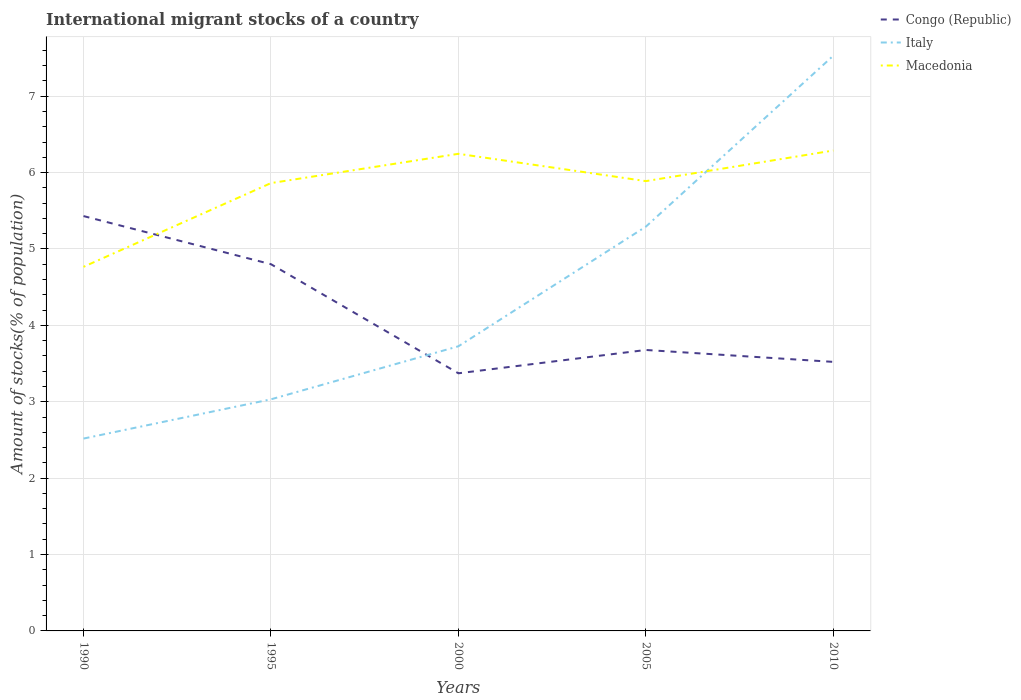Does the line corresponding to Macedonia intersect with the line corresponding to Congo (Republic)?
Provide a succinct answer. Yes. Is the number of lines equal to the number of legend labels?
Provide a short and direct response. Yes. Across all years, what is the maximum amount of stocks in in Macedonia?
Your answer should be compact. 4.77. What is the total amount of stocks in in Macedonia in the graph?
Your response must be concise. -0.38. What is the difference between the highest and the second highest amount of stocks in in Macedonia?
Your response must be concise. 1.52. What is the difference between the highest and the lowest amount of stocks in in Congo (Republic)?
Offer a terse response. 2. Is the amount of stocks in in Congo (Republic) strictly greater than the amount of stocks in in Italy over the years?
Ensure brevity in your answer.  No. How many lines are there?
Your answer should be compact. 3. Are the values on the major ticks of Y-axis written in scientific E-notation?
Offer a very short reply. No. Does the graph contain any zero values?
Make the answer very short. No. Where does the legend appear in the graph?
Provide a succinct answer. Top right. What is the title of the graph?
Your answer should be compact. International migrant stocks of a country. What is the label or title of the Y-axis?
Your response must be concise. Amount of stocks(% of population). What is the Amount of stocks(% of population) in Congo (Republic) in 1990?
Provide a short and direct response. 5.43. What is the Amount of stocks(% of population) in Italy in 1990?
Your response must be concise. 2.52. What is the Amount of stocks(% of population) of Macedonia in 1990?
Offer a terse response. 4.77. What is the Amount of stocks(% of population) in Congo (Republic) in 1995?
Your answer should be compact. 4.8. What is the Amount of stocks(% of population) of Italy in 1995?
Your response must be concise. 3.03. What is the Amount of stocks(% of population) of Macedonia in 1995?
Ensure brevity in your answer.  5.86. What is the Amount of stocks(% of population) in Congo (Republic) in 2000?
Ensure brevity in your answer.  3.37. What is the Amount of stocks(% of population) of Italy in 2000?
Offer a very short reply. 3.73. What is the Amount of stocks(% of population) in Macedonia in 2000?
Your response must be concise. 6.25. What is the Amount of stocks(% of population) of Congo (Republic) in 2005?
Keep it short and to the point. 3.68. What is the Amount of stocks(% of population) of Italy in 2005?
Ensure brevity in your answer.  5.29. What is the Amount of stocks(% of population) in Macedonia in 2005?
Provide a succinct answer. 5.89. What is the Amount of stocks(% of population) of Congo (Republic) in 2010?
Offer a very short reply. 3.52. What is the Amount of stocks(% of population) in Italy in 2010?
Make the answer very short. 7.53. What is the Amount of stocks(% of population) of Macedonia in 2010?
Your response must be concise. 6.29. Across all years, what is the maximum Amount of stocks(% of population) in Congo (Republic)?
Ensure brevity in your answer.  5.43. Across all years, what is the maximum Amount of stocks(% of population) in Italy?
Keep it short and to the point. 7.53. Across all years, what is the maximum Amount of stocks(% of population) in Macedonia?
Your answer should be very brief. 6.29. Across all years, what is the minimum Amount of stocks(% of population) in Congo (Republic)?
Give a very brief answer. 3.37. Across all years, what is the minimum Amount of stocks(% of population) in Italy?
Give a very brief answer. 2.52. Across all years, what is the minimum Amount of stocks(% of population) in Macedonia?
Make the answer very short. 4.77. What is the total Amount of stocks(% of population) of Congo (Republic) in the graph?
Offer a terse response. 20.8. What is the total Amount of stocks(% of population) in Italy in the graph?
Provide a succinct answer. 22.1. What is the total Amount of stocks(% of population) of Macedonia in the graph?
Your response must be concise. 29.05. What is the difference between the Amount of stocks(% of population) in Congo (Republic) in 1990 and that in 1995?
Ensure brevity in your answer.  0.63. What is the difference between the Amount of stocks(% of population) in Italy in 1990 and that in 1995?
Provide a succinct answer. -0.51. What is the difference between the Amount of stocks(% of population) of Macedonia in 1990 and that in 1995?
Give a very brief answer. -1.1. What is the difference between the Amount of stocks(% of population) of Congo (Republic) in 1990 and that in 2000?
Make the answer very short. 2.06. What is the difference between the Amount of stocks(% of population) of Italy in 1990 and that in 2000?
Give a very brief answer. -1.21. What is the difference between the Amount of stocks(% of population) of Macedonia in 1990 and that in 2000?
Make the answer very short. -1.48. What is the difference between the Amount of stocks(% of population) in Congo (Republic) in 1990 and that in 2005?
Ensure brevity in your answer.  1.75. What is the difference between the Amount of stocks(% of population) in Italy in 1990 and that in 2005?
Offer a terse response. -2.77. What is the difference between the Amount of stocks(% of population) in Macedonia in 1990 and that in 2005?
Offer a terse response. -1.12. What is the difference between the Amount of stocks(% of population) in Congo (Republic) in 1990 and that in 2010?
Offer a terse response. 1.91. What is the difference between the Amount of stocks(% of population) of Italy in 1990 and that in 2010?
Give a very brief answer. -5.01. What is the difference between the Amount of stocks(% of population) in Macedonia in 1990 and that in 2010?
Provide a succinct answer. -1.52. What is the difference between the Amount of stocks(% of population) in Congo (Republic) in 1995 and that in 2000?
Make the answer very short. 1.43. What is the difference between the Amount of stocks(% of population) in Italy in 1995 and that in 2000?
Give a very brief answer. -0.69. What is the difference between the Amount of stocks(% of population) of Macedonia in 1995 and that in 2000?
Keep it short and to the point. -0.38. What is the difference between the Amount of stocks(% of population) in Congo (Republic) in 1995 and that in 2005?
Your answer should be very brief. 1.12. What is the difference between the Amount of stocks(% of population) in Italy in 1995 and that in 2005?
Your response must be concise. -2.26. What is the difference between the Amount of stocks(% of population) of Macedonia in 1995 and that in 2005?
Your answer should be compact. -0.03. What is the difference between the Amount of stocks(% of population) of Congo (Republic) in 1995 and that in 2010?
Ensure brevity in your answer.  1.28. What is the difference between the Amount of stocks(% of population) in Italy in 1995 and that in 2010?
Make the answer very short. -4.5. What is the difference between the Amount of stocks(% of population) of Macedonia in 1995 and that in 2010?
Provide a short and direct response. -0.43. What is the difference between the Amount of stocks(% of population) in Congo (Republic) in 2000 and that in 2005?
Offer a very short reply. -0.31. What is the difference between the Amount of stocks(% of population) in Italy in 2000 and that in 2005?
Make the answer very short. -1.57. What is the difference between the Amount of stocks(% of population) in Macedonia in 2000 and that in 2005?
Your response must be concise. 0.36. What is the difference between the Amount of stocks(% of population) in Congo (Republic) in 2000 and that in 2010?
Your response must be concise. -0.15. What is the difference between the Amount of stocks(% of population) of Italy in 2000 and that in 2010?
Provide a short and direct response. -3.8. What is the difference between the Amount of stocks(% of population) of Macedonia in 2000 and that in 2010?
Your answer should be very brief. -0.04. What is the difference between the Amount of stocks(% of population) of Congo (Republic) in 2005 and that in 2010?
Your response must be concise. 0.16. What is the difference between the Amount of stocks(% of population) of Italy in 2005 and that in 2010?
Make the answer very short. -2.24. What is the difference between the Amount of stocks(% of population) of Macedonia in 2005 and that in 2010?
Offer a very short reply. -0.4. What is the difference between the Amount of stocks(% of population) of Congo (Republic) in 1990 and the Amount of stocks(% of population) of Italy in 1995?
Provide a succinct answer. 2.4. What is the difference between the Amount of stocks(% of population) of Congo (Republic) in 1990 and the Amount of stocks(% of population) of Macedonia in 1995?
Your answer should be compact. -0.43. What is the difference between the Amount of stocks(% of population) of Italy in 1990 and the Amount of stocks(% of population) of Macedonia in 1995?
Your response must be concise. -3.34. What is the difference between the Amount of stocks(% of population) of Congo (Republic) in 1990 and the Amount of stocks(% of population) of Italy in 2000?
Ensure brevity in your answer.  1.7. What is the difference between the Amount of stocks(% of population) in Congo (Republic) in 1990 and the Amount of stocks(% of population) in Macedonia in 2000?
Your answer should be compact. -0.82. What is the difference between the Amount of stocks(% of population) in Italy in 1990 and the Amount of stocks(% of population) in Macedonia in 2000?
Offer a terse response. -3.73. What is the difference between the Amount of stocks(% of population) in Congo (Republic) in 1990 and the Amount of stocks(% of population) in Italy in 2005?
Keep it short and to the point. 0.14. What is the difference between the Amount of stocks(% of population) in Congo (Republic) in 1990 and the Amount of stocks(% of population) in Macedonia in 2005?
Your answer should be compact. -0.46. What is the difference between the Amount of stocks(% of population) in Italy in 1990 and the Amount of stocks(% of population) in Macedonia in 2005?
Provide a short and direct response. -3.37. What is the difference between the Amount of stocks(% of population) in Congo (Republic) in 1990 and the Amount of stocks(% of population) in Italy in 2010?
Your answer should be compact. -2.1. What is the difference between the Amount of stocks(% of population) of Congo (Republic) in 1990 and the Amount of stocks(% of population) of Macedonia in 2010?
Your response must be concise. -0.86. What is the difference between the Amount of stocks(% of population) of Italy in 1990 and the Amount of stocks(% of population) of Macedonia in 2010?
Ensure brevity in your answer.  -3.77. What is the difference between the Amount of stocks(% of population) of Congo (Republic) in 1995 and the Amount of stocks(% of population) of Italy in 2000?
Provide a short and direct response. 1.07. What is the difference between the Amount of stocks(% of population) of Congo (Republic) in 1995 and the Amount of stocks(% of population) of Macedonia in 2000?
Ensure brevity in your answer.  -1.45. What is the difference between the Amount of stocks(% of population) of Italy in 1995 and the Amount of stocks(% of population) of Macedonia in 2000?
Your answer should be very brief. -3.21. What is the difference between the Amount of stocks(% of population) in Congo (Republic) in 1995 and the Amount of stocks(% of population) in Italy in 2005?
Provide a succinct answer. -0.49. What is the difference between the Amount of stocks(% of population) of Congo (Republic) in 1995 and the Amount of stocks(% of population) of Macedonia in 2005?
Provide a succinct answer. -1.09. What is the difference between the Amount of stocks(% of population) in Italy in 1995 and the Amount of stocks(% of population) in Macedonia in 2005?
Ensure brevity in your answer.  -2.86. What is the difference between the Amount of stocks(% of population) in Congo (Republic) in 1995 and the Amount of stocks(% of population) in Italy in 2010?
Give a very brief answer. -2.73. What is the difference between the Amount of stocks(% of population) of Congo (Republic) in 1995 and the Amount of stocks(% of population) of Macedonia in 2010?
Keep it short and to the point. -1.49. What is the difference between the Amount of stocks(% of population) of Italy in 1995 and the Amount of stocks(% of population) of Macedonia in 2010?
Keep it short and to the point. -3.26. What is the difference between the Amount of stocks(% of population) of Congo (Republic) in 2000 and the Amount of stocks(% of population) of Italy in 2005?
Make the answer very short. -1.92. What is the difference between the Amount of stocks(% of population) in Congo (Republic) in 2000 and the Amount of stocks(% of population) in Macedonia in 2005?
Your response must be concise. -2.52. What is the difference between the Amount of stocks(% of population) of Italy in 2000 and the Amount of stocks(% of population) of Macedonia in 2005?
Provide a short and direct response. -2.16. What is the difference between the Amount of stocks(% of population) of Congo (Republic) in 2000 and the Amount of stocks(% of population) of Italy in 2010?
Keep it short and to the point. -4.16. What is the difference between the Amount of stocks(% of population) of Congo (Republic) in 2000 and the Amount of stocks(% of population) of Macedonia in 2010?
Provide a short and direct response. -2.92. What is the difference between the Amount of stocks(% of population) of Italy in 2000 and the Amount of stocks(% of population) of Macedonia in 2010?
Provide a succinct answer. -2.56. What is the difference between the Amount of stocks(% of population) in Congo (Republic) in 2005 and the Amount of stocks(% of population) in Italy in 2010?
Your answer should be compact. -3.85. What is the difference between the Amount of stocks(% of population) in Congo (Republic) in 2005 and the Amount of stocks(% of population) in Macedonia in 2010?
Keep it short and to the point. -2.61. What is the difference between the Amount of stocks(% of population) in Italy in 2005 and the Amount of stocks(% of population) in Macedonia in 2010?
Provide a succinct answer. -1. What is the average Amount of stocks(% of population) of Congo (Republic) per year?
Keep it short and to the point. 4.16. What is the average Amount of stocks(% of population) of Italy per year?
Keep it short and to the point. 4.42. What is the average Amount of stocks(% of population) in Macedonia per year?
Offer a terse response. 5.81. In the year 1990, what is the difference between the Amount of stocks(% of population) of Congo (Republic) and Amount of stocks(% of population) of Italy?
Provide a short and direct response. 2.91. In the year 1990, what is the difference between the Amount of stocks(% of population) of Congo (Republic) and Amount of stocks(% of population) of Macedonia?
Your response must be concise. 0.66. In the year 1990, what is the difference between the Amount of stocks(% of population) of Italy and Amount of stocks(% of population) of Macedonia?
Provide a short and direct response. -2.25. In the year 1995, what is the difference between the Amount of stocks(% of population) of Congo (Republic) and Amount of stocks(% of population) of Italy?
Give a very brief answer. 1.77. In the year 1995, what is the difference between the Amount of stocks(% of population) in Congo (Republic) and Amount of stocks(% of population) in Macedonia?
Your response must be concise. -1.06. In the year 1995, what is the difference between the Amount of stocks(% of population) of Italy and Amount of stocks(% of population) of Macedonia?
Your answer should be compact. -2.83. In the year 2000, what is the difference between the Amount of stocks(% of population) of Congo (Republic) and Amount of stocks(% of population) of Italy?
Your response must be concise. -0.35. In the year 2000, what is the difference between the Amount of stocks(% of population) of Congo (Republic) and Amount of stocks(% of population) of Macedonia?
Ensure brevity in your answer.  -2.87. In the year 2000, what is the difference between the Amount of stocks(% of population) in Italy and Amount of stocks(% of population) in Macedonia?
Your answer should be very brief. -2.52. In the year 2005, what is the difference between the Amount of stocks(% of population) of Congo (Republic) and Amount of stocks(% of population) of Italy?
Give a very brief answer. -1.61. In the year 2005, what is the difference between the Amount of stocks(% of population) of Congo (Republic) and Amount of stocks(% of population) of Macedonia?
Your response must be concise. -2.21. In the year 2005, what is the difference between the Amount of stocks(% of population) of Italy and Amount of stocks(% of population) of Macedonia?
Make the answer very short. -0.6. In the year 2010, what is the difference between the Amount of stocks(% of population) in Congo (Republic) and Amount of stocks(% of population) in Italy?
Keep it short and to the point. -4.01. In the year 2010, what is the difference between the Amount of stocks(% of population) of Congo (Republic) and Amount of stocks(% of population) of Macedonia?
Provide a succinct answer. -2.77. In the year 2010, what is the difference between the Amount of stocks(% of population) of Italy and Amount of stocks(% of population) of Macedonia?
Give a very brief answer. 1.24. What is the ratio of the Amount of stocks(% of population) in Congo (Republic) in 1990 to that in 1995?
Provide a short and direct response. 1.13. What is the ratio of the Amount of stocks(% of population) of Italy in 1990 to that in 1995?
Ensure brevity in your answer.  0.83. What is the ratio of the Amount of stocks(% of population) in Macedonia in 1990 to that in 1995?
Offer a terse response. 0.81. What is the ratio of the Amount of stocks(% of population) of Congo (Republic) in 1990 to that in 2000?
Your response must be concise. 1.61. What is the ratio of the Amount of stocks(% of population) of Italy in 1990 to that in 2000?
Ensure brevity in your answer.  0.68. What is the ratio of the Amount of stocks(% of population) of Macedonia in 1990 to that in 2000?
Keep it short and to the point. 0.76. What is the ratio of the Amount of stocks(% of population) in Congo (Republic) in 1990 to that in 2005?
Make the answer very short. 1.48. What is the ratio of the Amount of stocks(% of population) of Italy in 1990 to that in 2005?
Ensure brevity in your answer.  0.48. What is the ratio of the Amount of stocks(% of population) of Macedonia in 1990 to that in 2005?
Provide a succinct answer. 0.81. What is the ratio of the Amount of stocks(% of population) in Congo (Republic) in 1990 to that in 2010?
Your answer should be very brief. 1.54. What is the ratio of the Amount of stocks(% of population) of Italy in 1990 to that in 2010?
Your response must be concise. 0.33. What is the ratio of the Amount of stocks(% of population) of Macedonia in 1990 to that in 2010?
Provide a succinct answer. 0.76. What is the ratio of the Amount of stocks(% of population) of Congo (Republic) in 1995 to that in 2000?
Offer a terse response. 1.42. What is the ratio of the Amount of stocks(% of population) in Italy in 1995 to that in 2000?
Offer a very short reply. 0.81. What is the ratio of the Amount of stocks(% of population) in Macedonia in 1995 to that in 2000?
Provide a succinct answer. 0.94. What is the ratio of the Amount of stocks(% of population) in Congo (Republic) in 1995 to that in 2005?
Ensure brevity in your answer.  1.31. What is the ratio of the Amount of stocks(% of population) of Italy in 1995 to that in 2005?
Offer a very short reply. 0.57. What is the ratio of the Amount of stocks(% of population) in Macedonia in 1995 to that in 2005?
Offer a very short reply. 1. What is the ratio of the Amount of stocks(% of population) of Congo (Republic) in 1995 to that in 2010?
Make the answer very short. 1.36. What is the ratio of the Amount of stocks(% of population) in Italy in 1995 to that in 2010?
Your response must be concise. 0.4. What is the ratio of the Amount of stocks(% of population) of Macedonia in 1995 to that in 2010?
Provide a short and direct response. 0.93. What is the ratio of the Amount of stocks(% of population) in Congo (Republic) in 2000 to that in 2005?
Provide a succinct answer. 0.92. What is the ratio of the Amount of stocks(% of population) of Italy in 2000 to that in 2005?
Make the answer very short. 0.7. What is the ratio of the Amount of stocks(% of population) in Macedonia in 2000 to that in 2005?
Your answer should be very brief. 1.06. What is the ratio of the Amount of stocks(% of population) of Congo (Republic) in 2000 to that in 2010?
Make the answer very short. 0.96. What is the ratio of the Amount of stocks(% of population) in Italy in 2000 to that in 2010?
Offer a terse response. 0.49. What is the ratio of the Amount of stocks(% of population) in Congo (Republic) in 2005 to that in 2010?
Provide a succinct answer. 1.04. What is the ratio of the Amount of stocks(% of population) of Italy in 2005 to that in 2010?
Provide a succinct answer. 0.7. What is the ratio of the Amount of stocks(% of population) in Macedonia in 2005 to that in 2010?
Offer a terse response. 0.94. What is the difference between the highest and the second highest Amount of stocks(% of population) of Congo (Republic)?
Your answer should be compact. 0.63. What is the difference between the highest and the second highest Amount of stocks(% of population) in Italy?
Ensure brevity in your answer.  2.24. What is the difference between the highest and the second highest Amount of stocks(% of population) in Macedonia?
Ensure brevity in your answer.  0.04. What is the difference between the highest and the lowest Amount of stocks(% of population) of Congo (Republic)?
Provide a succinct answer. 2.06. What is the difference between the highest and the lowest Amount of stocks(% of population) of Italy?
Your answer should be compact. 5.01. What is the difference between the highest and the lowest Amount of stocks(% of population) in Macedonia?
Your response must be concise. 1.52. 